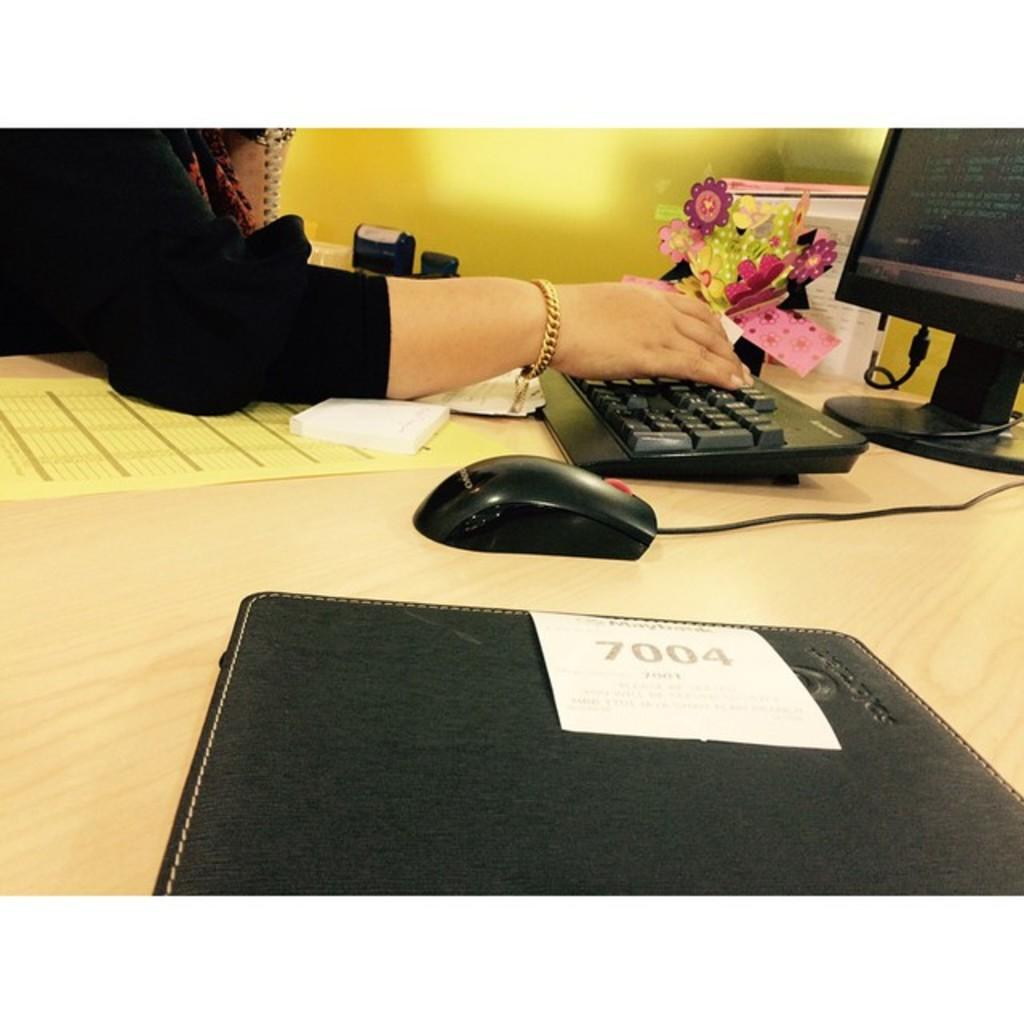What is on the table in the image? There is a file, a monitor, a keyboard, a mouse, and two papers on the table. What is the lady wearing in the image? The lady is wearing a black t-shirt. What is the lady doing in the image? The lady is touching the keyboard. Can you describe the paper on the table? There is a colorful paper on the table. What type of coil is present on the table in the image? There is no coil present on the table in the image. What kind of toys can be seen in the image? There are no toys visible in the image. 